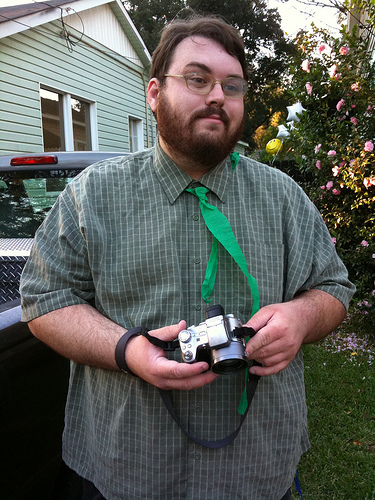What kind of photographic equipment does the man have? The man is holding what appears to be a vintage film camera, suitable for analog photography. How do his glasses complement his activity? His glasses likely aid in the precise focusing and framing of his photographs, enhancing his visual acuity for such detailed work. 